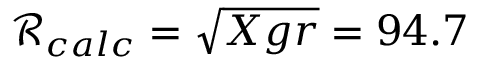Convert formula to latex. <formula><loc_0><loc_0><loc_500><loc_500>\mathcal { R } _ { c a l c } = \sqrt { X g r } = 9 4 . 7</formula> 